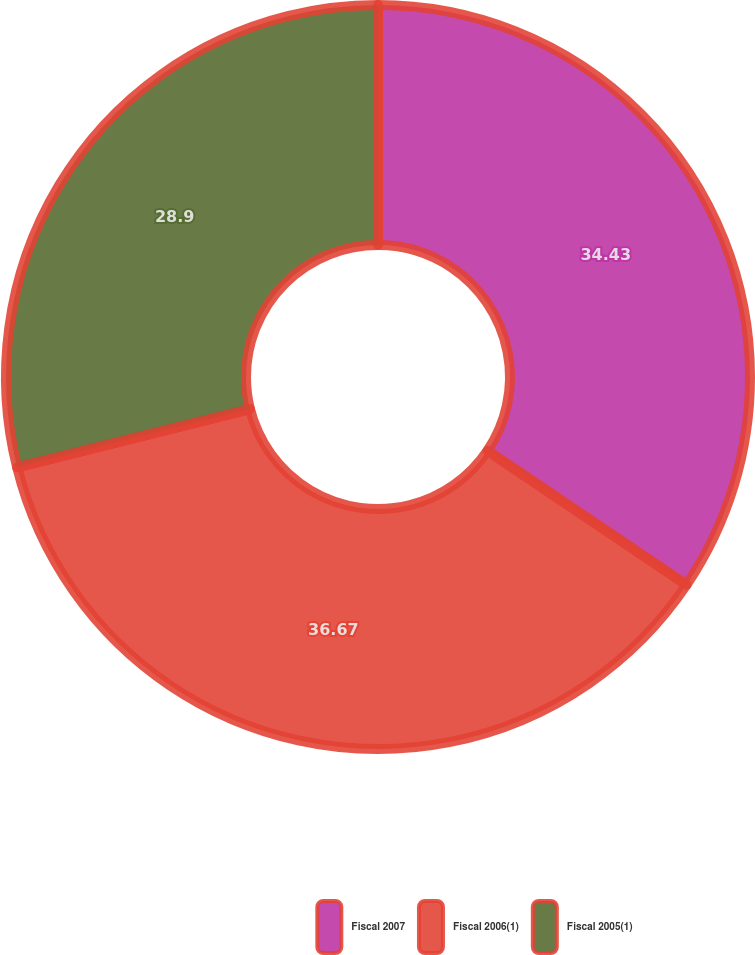Convert chart to OTSL. <chart><loc_0><loc_0><loc_500><loc_500><pie_chart><fcel>Fiscal 2007<fcel>Fiscal 2006(1)<fcel>Fiscal 2005(1)<nl><fcel>34.43%<fcel>36.66%<fcel>28.9%<nl></chart> 